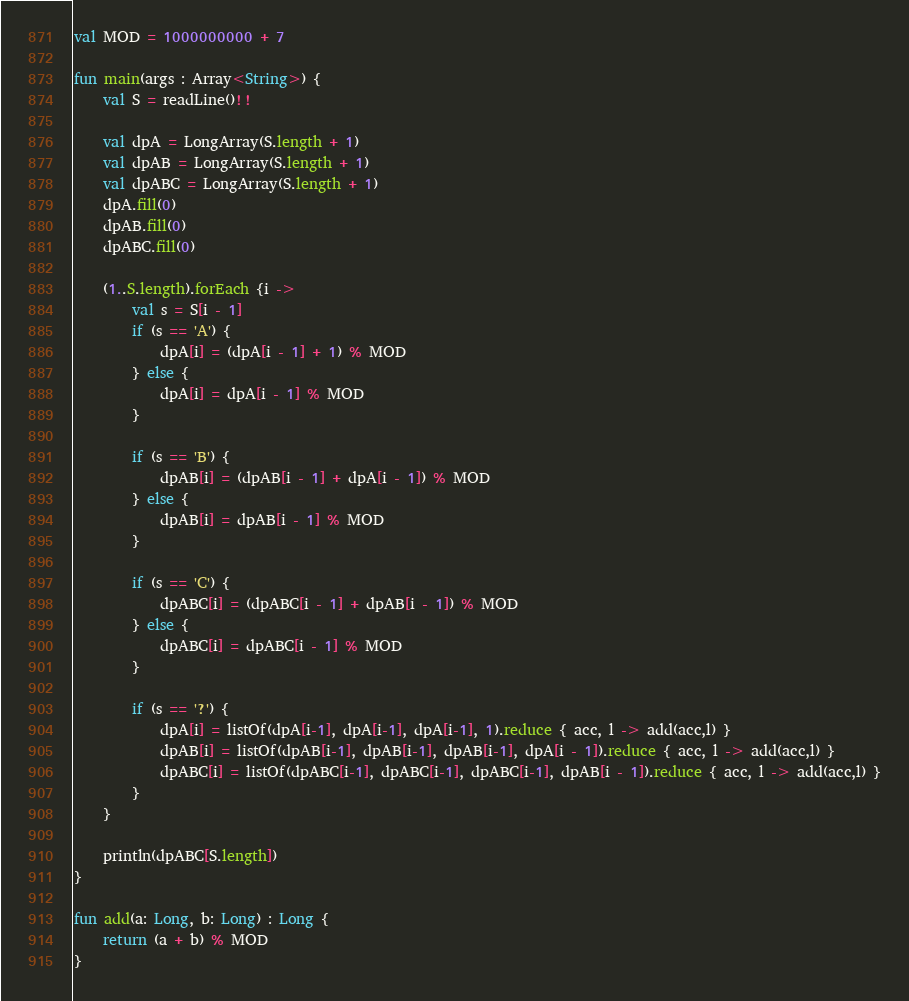Convert code to text. <code><loc_0><loc_0><loc_500><loc_500><_Kotlin_>val MOD = 1000000000 + 7

fun main(args : Array<String>) {
    val S = readLine()!!

    val dpA = LongArray(S.length + 1)
    val dpAB = LongArray(S.length + 1)
    val dpABC = LongArray(S.length + 1)
    dpA.fill(0)
    dpAB.fill(0)
    dpABC.fill(0)

    (1..S.length).forEach {i ->
        val s = S[i - 1]
        if (s == 'A') {
            dpA[i] = (dpA[i - 1] + 1) % MOD
        } else {
            dpA[i] = dpA[i - 1] % MOD
        }

        if (s == 'B') {
            dpAB[i] = (dpAB[i - 1] + dpA[i - 1]) % MOD
        } else {
            dpAB[i] = dpAB[i - 1] % MOD
        }

        if (s == 'C') {
            dpABC[i] = (dpABC[i - 1] + dpAB[i - 1]) % MOD
        } else {
            dpABC[i] = dpABC[i - 1] % MOD
        }

        if (s == '?') {
            dpA[i] = listOf(dpA[i-1], dpA[i-1], dpA[i-1], 1).reduce { acc, l -> add(acc,l) }
            dpAB[i] = listOf(dpAB[i-1], dpAB[i-1], dpAB[i-1], dpA[i - 1]).reduce { acc, l -> add(acc,l) }
            dpABC[i] = listOf(dpABC[i-1], dpABC[i-1], dpABC[i-1], dpAB[i - 1]).reduce { acc, l -> add(acc,l) }
        }
    }

    println(dpABC[S.length])
}

fun add(a: Long, b: Long) : Long {
    return (a + b) % MOD
}</code> 